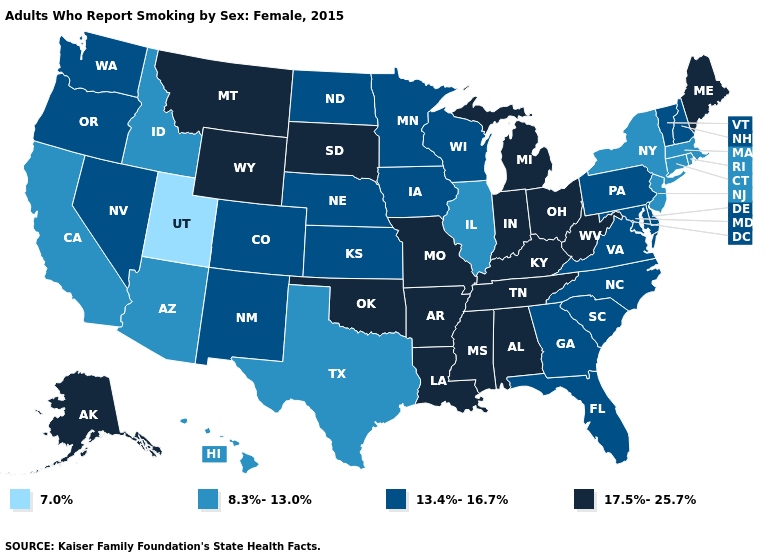What is the value of California?
Write a very short answer. 8.3%-13.0%. What is the value of Pennsylvania?
Quick response, please. 13.4%-16.7%. What is the value of Oklahoma?
Be succinct. 17.5%-25.7%. Does Utah have the lowest value in the USA?
Short answer required. Yes. What is the value of Maine?
Short answer required. 17.5%-25.7%. Does Indiana have a higher value than New Jersey?
Keep it brief. Yes. Is the legend a continuous bar?
Concise answer only. No. What is the value of Oklahoma?
Be succinct. 17.5%-25.7%. How many symbols are there in the legend?
Be succinct. 4. Does Mississippi have a lower value than Massachusetts?
Quick response, please. No. Does Alabama have the lowest value in the South?
Concise answer only. No. What is the highest value in states that border Wisconsin?
Keep it brief. 17.5%-25.7%. Does Illinois have the highest value in the MidWest?
Write a very short answer. No. Among the states that border New Hampshire , which have the highest value?
Keep it brief. Maine. What is the value of California?
Be succinct. 8.3%-13.0%. 